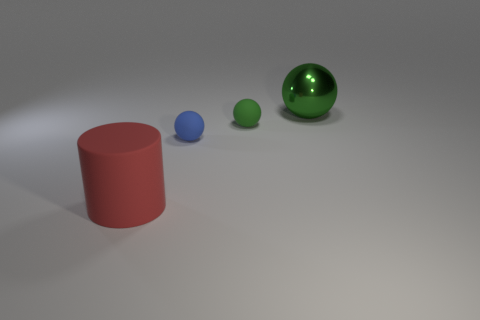There is a rubber object that is left of the blue ball; is its shape the same as the small object behind the small blue object?
Your answer should be very brief. No. Is there anything else of the same color as the matte cylinder?
Ensure brevity in your answer.  No. There is a small green object that is the same material as the large red thing; what shape is it?
Offer a terse response. Sphere. What is the material of the ball that is both in front of the big metallic sphere and behind the small blue ball?
Your answer should be very brief. Rubber. Do the large matte thing and the big shiny object have the same color?
Your answer should be very brief. No. There is another thing that is the same color as the shiny thing; what shape is it?
Offer a very short reply. Sphere. What number of other blue things are the same shape as the tiny blue rubber object?
Provide a succinct answer. 0. There is another ball that is made of the same material as the tiny green ball; what size is it?
Provide a succinct answer. Small. Is the size of the blue matte sphere the same as the red rubber cylinder?
Keep it short and to the point. No. Are any red objects visible?
Your answer should be compact. Yes. 